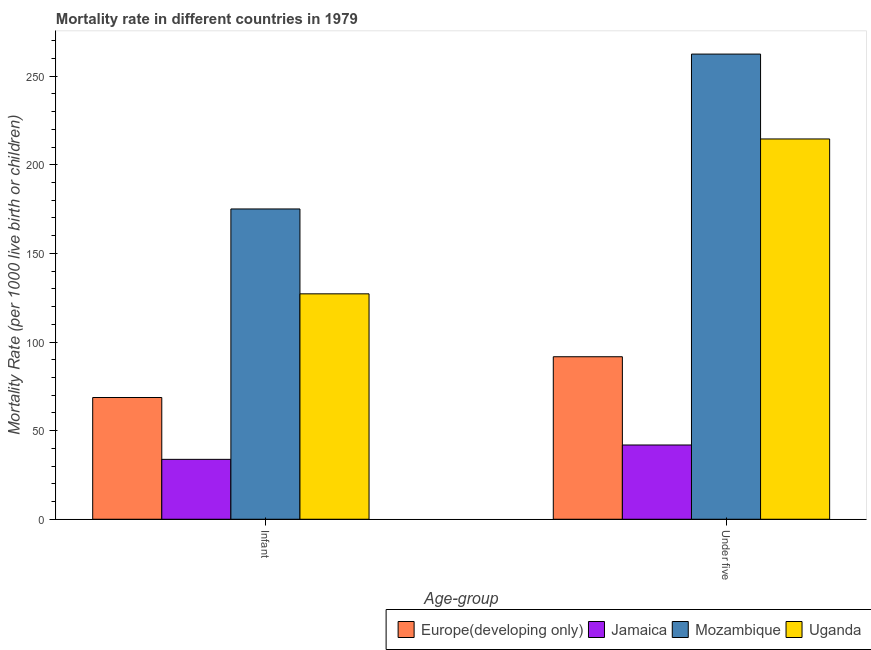Are the number of bars on each tick of the X-axis equal?
Your answer should be very brief. Yes. How many bars are there on the 2nd tick from the left?
Make the answer very short. 4. How many bars are there on the 2nd tick from the right?
Ensure brevity in your answer.  4. What is the label of the 1st group of bars from the left?
Provide a short and direct response. Infant. What is the infant mortality rate in Mozambique?
Your answer should be very brief. 175.1. Across all countries, what is the maximum under-5 mortality rate?
Offer a very short reply. 262.5. Across all countries, what is the minimum infant mortality rate?
Your response must be concise. 33.8. In which country was the under-5 mortality rate maximum?
Offer a very short reply. Mozambique. In which country was the under-5 mortality rate minimum?
Your response must be concise. Jamaica. What is the total under-5 mortality rate in the graph?
Your response must be concise. 610.7. What is the difference between the under-5 mortality rate in Europe(developing only) and that in Jamaica?
Offer a terse response. 49.8. What is the difference between the under-5 mortality rate in Jamaica and the infant mortality rate in Mozambique?
Ensure brevity in your answer.  -133.2. What is the average infant mortality rate per country?
Keep it short and to the point. 101.2. What is the difference between the under-5 mortality rate and infant mortality rate in Jamaica?
Offer a terse response. 8.1. What is the ratio of the under-5 mortality rate in Jamaica to that in Mozambique?
Your answer should be very brief. 0.16. Is the infant mortality rate in Uganda less than that in Mozambique?
Your response must be concise. Yes. In how many countries, is the under-5 mortality rate greater than the average under-5 mortality rate taken over all countries?
Your response must be concise. 2. What does the 2nd bar from the left in Infant represents?
Offer a terse response. Jamaica. What does the 1st bar from the right in Under five represents?
Your answer should be very brief. Uganda. How many bars are there?
Your answer should be very brief. 8. Are the values on the major ticks of Y-axis written in scientific E-notation?
Give a very brief answer. No. Where does the legend appear in the graph?
Your response must be concise. Bottom right. How many legend labels are there?
Your answer should be compact. 4. How are the legend labels stacked?
Your answer should be very brief. Horizontal. What is the title of the graph?
Keep it short and to the point. Mortality rate in different countries in 1979. What is the label or title of the X-axis?
Give a very brief answer. Age-group. What is the label or title of the Y-axis?
Offer a terse response. Mortality Rate (per 1000 live birth or children). What is the Mortality Rate (per 1000 live birth or children) in Europe(developing only) in Infant?
Your response must be concise. 68.7. What is the Mortality Rate (per 1000 live birth or children) in Jamaica in Infant?
Ensure brevity in your answer.  33.8. What is the Mortality Rate (per 1000 live birth or children) of Mozambique in Infant?
Keep it short and to the point. 175.1. What is the Mortality Rate (per 1000 live birth or children) of Uganda in Infant?
Your answer should be compact. 127.2. What is the Mortality Rate (per 1000 live birth or children) in Europe(developing only) in Under five?
Your answer should be compact. 91.7. What is the Mortality Rate (per 1000 live birth or children) of Jamaica in Under five?
Make the answer very short. 41.9. What is the Mortality Rate (per 1000 live birth or children) of Mozambique in Under five?
Offer a terse response. 262.5. What is the Mortality Rate (per 1000 live birth or children) of Uganda in Under five?
Give a very brief answer. 214.6. Across all Age-group, what is the maximum Mortality Rate (per 1000 live birth or children) of Europe(developing only)?
Your answer should be compact. 91.7. Across all Age-group, what is the maximum Mortality Rate (per 1000 live birth or children) in Jamaica?
Keep it short and to the point. 41.9. Across all Age-group, what is the maximum Mortality Rate (per 1000 live birth or children) in Mozambique?
Provide a short and direct response. 262.5. Across all Age-group, what is the maximum Mortality Rate (per 1000 live birth or children) of Uganda?
Ensure brevity in your answer.  214.6. Across all Age-group, what is the minimum Mortality Rate (per 1000 live birth or children) in Europe(developing only)?
Give a very brief answer. 68.7. Across all Age-group, what is the minimum Mortality Rate (per 1000 live birth or children) of Jamaica?
Your answer should be compact. 33.8. Across all Age-group, what is the minimum Mortality Rate (per 1000 live birth or children) in Mozambique?
Keep it short and to the point. 175.1. Across all Age-group, what is the minimum Mortality Rate (per 1000 live birth or children) of Uganda?
Your answer should be compact. 127.2. What is the total Mortality Rate (per 1000 live birth or children) of Europe(developing only) in the graph?
Make the answer very short. 160.4. What is the total Mortality Rate (per 1000 live birth or children) of Jamaica in the graph?
Keep it short and to the point. 75.7. What is the total Mortality Rate (per 1000 live birth or children) in Mozambique in the graph?
Give a very brief answer. 437.6. What is the total Mortality Rate (per 1000 live birth or children) in Uganda in the graph?
Keep it short and to the point. 341.8. What is the difference between the Mortality Rate (per 1000 live birth or children) in Europe(developing only) in Infant and that in Under five?
Offer a terse response. -23. What is the difference between the Mortality Rate (per 1000 live birth or children) of Jamaica in Infant and that in Under five?
Provide a succinct answer. -8.1. What is the difference between the Mortality Rate (per 1000 live birth or children) of Mozambique in Infant and that in Under five?
Your answer should be very brief. -87.4. What is the difference between the Mortality Rate (per 1000 live birth or children) in Uganda in Infant and that in Under five?
Give a very brief answer. -87.4. What is the difference between the Mortality Rate (per 1000 live birth or children) of Europe(developing only) in Infant and the Mortality Rate (per 1000 live birth or children) of Jamaica in Under five?
Make the answer very short. 26.8. What is the difference between the Mortality Rate (per 1000 live birth or children) of Europe(developing only) in Infant and the Mortality Rate (per 1000 live birth or children) of Mozambique in Under five?
Provide a succinct answer. -193.8. What is the difference between the Mortality Rate (per 1000 live birth or children) of Europe(developing only) in Infant and the Mortality Rate (per 1000 live birth or children) of Uganda in Under five?
Ensure brevity in your answer.  -145.9. What is the difference between the Mortality Rate (per 1000 live birth or children) in Jamaica in Infant and the Mortality Rate (per 1000 live birth or children) in Mozambique in Under five?
Offer a very short reply. -228.7. What is the difference between the Mortality Rate (per 1000 live birth or children) of Jamaica in Infant and the Mortality Rate (per 1000 live birth or children) of Uganda in Under five?
Give a very brief answer. -180.8. What is the difference between the Mortality Rate (per 1000 live birth or children) in Mozambique in Infant and the Mortality Rate (per 1000 live birth or children) in Uganda in Under five?
Your answer should be very brief. -39.5. What is the average Mortality Rate (per 1000 live birth or children) of Europe(developing only) per Age-group?
Offer a terse response. 80.2. What is the average Mortality Rate (per 1000 live birth or children) of Jamaica per Age-group?
Your response must be concise. 37.85. What is the average Mortality Rate (per 1000 live birth or children) in Mozambique per Age-group?
Your answer should be compact. 218.8. What is the average Mortality Rate (per 1000 live birth or children) of Uganda per Age-group?
Offer a terse response. 170.9. What is the difference between the Mortality Rate (per 1000 live birth or children) in Europe(developing only) and Mortality Rate (per 1000 live birth or children) in Jamaica in Infant?
Offer a very short reply. 34.9. What is the difference between the Mortality Rate (per 1000 live birth or children) of Europe(developing only) and Mortality Rate (per 1000 live birth or children) of Mozambique in Infant?
Provide a short and direct response. -106.4. What is the difference between the Mortality Rate (per 1000 live birth or children) in Europe(developing only) and Mortality Rate (per 1000 live birth or children) in Uganda in Infant?
Offer a terse response. -58.5. What is the difference between the Mortality Rate (per 1000 live birth or children) of Jamaica and Mortality Rate (per 1000 live birth or children) of Mozambique in Infant?
Provide a succinct answer. -141.3. What is the difference between the Mortality Rate (per 1000 live birth or children) in Jamaica and Mortality Rate (per 1000 live birth or children) in Uganda in Infant?
Offer a very short reply. -93.4. What is the difference between the Mortality Rate (per 1000 live birth or children) of Mozambique and Mortality Rate (per 1000 live birth or children) of Uganda in Infant?
Offer a terse response. 47.9. What is the difference between the Mortality Rate (per 1000 live birth or children) of Europe(developing only) and Mortality Rate (per 1000 live birth or children) of Jamaica in Under five?
Give a very brief answer. 49.8. What is the difference between the Mortality Rate (per 1000 live birth or children) of Europe(developing only) and Mortality Rate (per 1000 live birth or children) of Mozambique in Under five?
Make the answer very short. -170.8. What is the difference between the Mortality Rate (per 1000 live birth or children) in Europe(developing only) and Mortality Rate (per 1000 live birth or children) in Uganda in Under five?
Your response must be concise. -122.9. What is the difference between the Mortality Rate (per 1000 live birth or children) in Jamaica and Mortality Rate (per 1000 live birth or children) in Mozambique in Under five?
Offer a very short reply. -220.6. What is the difference between the Mortality Rate (per 1000 live birth or children) in Jamaica and Mortality Rate (per 1000 live birth or children) in Uganda in Under five?
Give a very brief answer. -172.7. What is the difference between the Mortality Rate (per 1000 live birth or children) of Mozambique and Mortality Rate (per 1000 live birth or children) of Uganda in Under five?
Offer a terse response. 47.9. What is the ratio of the Mortality Rate (per 1000 live birth or children) of Europe(developing only) in Infant to that in Under five?
Your answer should be very brief. 0.75. What is the ratio of the Mortality Rate (per 1000 live birth or children) in Jamaica in Infant to that in Under five?
Your response must be concise. 0.81. What is the ratio of the Mortality Rate (per 1000 live birth or children) in Mozambique in Infant to that in Under five?
Your answer should be compact. 0.67. What is the ratio of the Mortality Rate (per 1000 live birth or children) in Uganda in Infant to that in Under five?
Make the answer very short. 0.59. What is the difference between the highest and the second highest Mortality Rate (per 1000 live birth or children) of Mozambique?
Give a very brief answer. 87.4. What is the difference between the highest and the second highest Mortality Rate (per 1000 live birth or children) of Uganda?
Make the answer very short. 87.4. What is the difference between the highest and the lowest Mortality Rate (per 1000 live birth or children) of Europe(developing only)?
Give a very brief answer. 23. What is the difference between the highest and the lowest Mortality Rate (per 1000 live birth or children) of Jamaica?
Your response must be concise. 8.1. What is the difference between the highest and the lowest Mortality Rate (per 1000 live birth or children) in Mozambique?
Your response must be concise. 87.4. What is the difference between the highest and the lowest Mortality Rate (per 1000 live birth or children) in Uganda?
Keep it short and to the point. 87.4. 